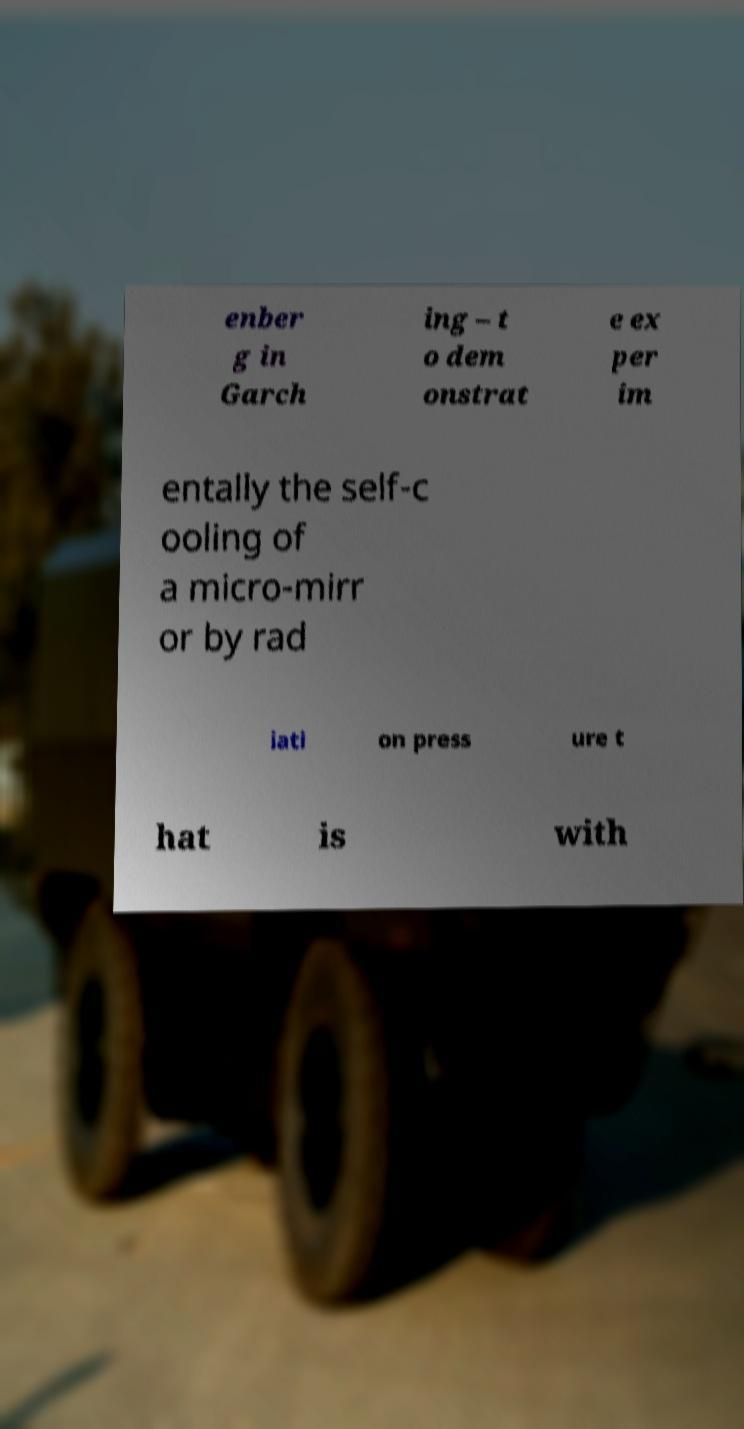Could you assist in decoding the text presented in this image and type it out clearly? enber g in Garch ing – t o dem onstrat e ex per im entally the self-c ooling of a micro-mirr or by rad iati on press ure t hat is with 